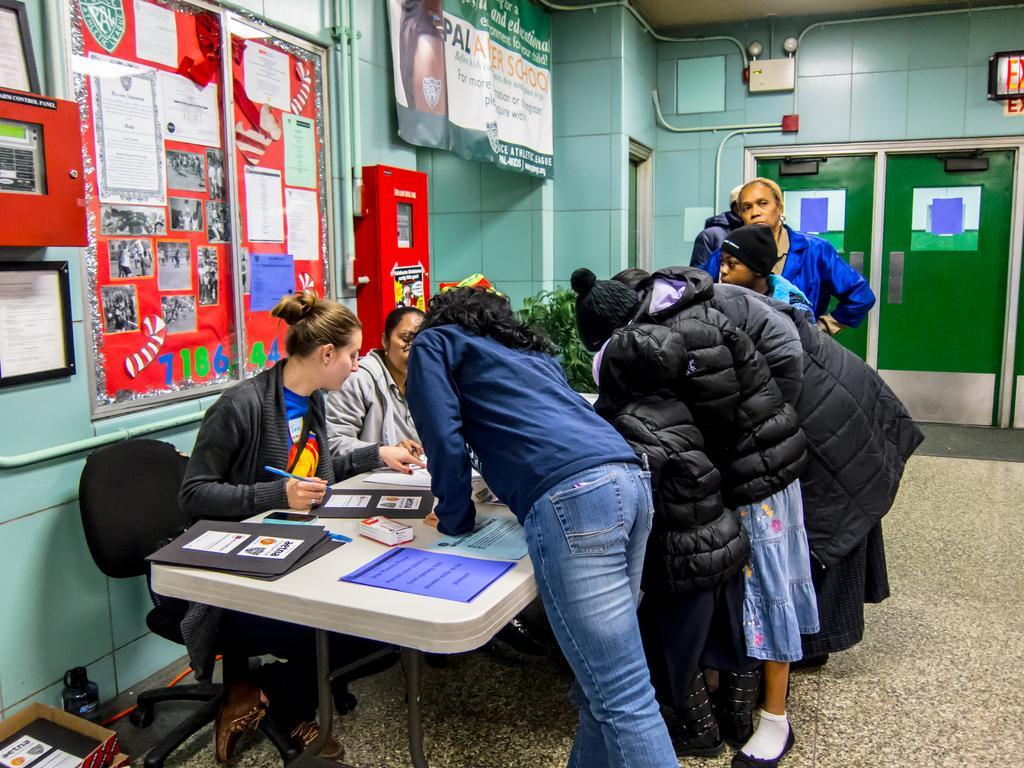How would you summarize this image in a sentence or two? Here I can see two women are sitting on the chairs in front of the table and writing something on the papers with a pen. On the table I can see few files and papers. On the other side of the table few people are wearing black color jackets and standing. At the back there is a wall to which I can see papers, photos and some machines are attached. On the top of the image I can see a banner which is hanging to the wall. On the left bottom of the image I can see a box and a bottle on the floor. 